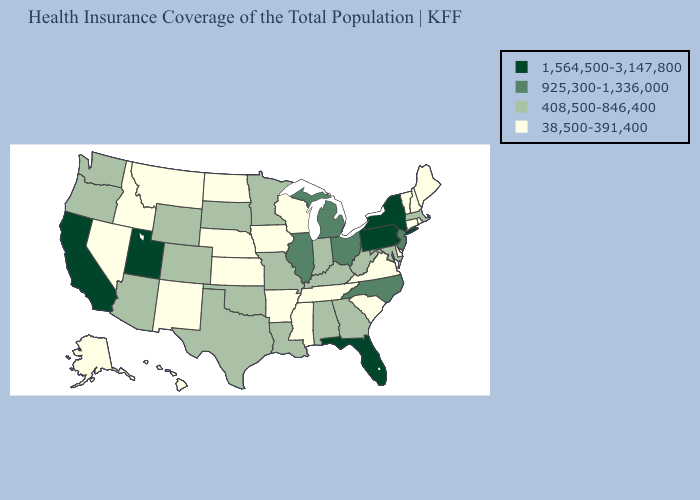What is the value of Washington?
Answer briefly. 408,500-846,400. Does Illinois have a higher value than Florida?
Keep it brief. No. Name the states that have a value in the range 408,500-846,400?
Short answer required. Alabama, Arizona, Colorado, Georgia, Indiana, Kentucky, Louisiana, Maryland, Massachusetts, Minnesota, Missouri, Oklahoma, Oregon, South Dakota, Texas, Washington, West Virginia, Wyoming. What is the lowest value in the MidWest?
Concise answer only. 38,500-391,400. Name the states that have a value in the range 925,300-1,336,000?
Write a very short answer. Illinois, Michigan, New Jersey, North Carolina, Ohio. Name the states that have a value in the range 1,564,500-3,147,800?
Keep it brief. California, Florida, New York, Pennsylvania, Utah. Does Montana have the lowest value in the West?
Quick response, please. Yes. Among the states that border Idaho , which have the lowest value?
Answer briefly. Montana, Nevada. Which states hav the highest value in the Northeast?
Be succinct. New York, Pennsylvania. Which states have the highest value in the USA?
Quick response, please. California, Florida, New York, Pennsylvania, Utah. What is the lowest value in the South?
Be succinct. 38,500-391,400. What is the highest value in the USA?
Give a very brief answer. 1,564,500-3,147,800. Does Alabama have the highest value in the USA?
Keep it brief. No. What is the value of Nebraska?
Short answer required. 38,500-391,400. 